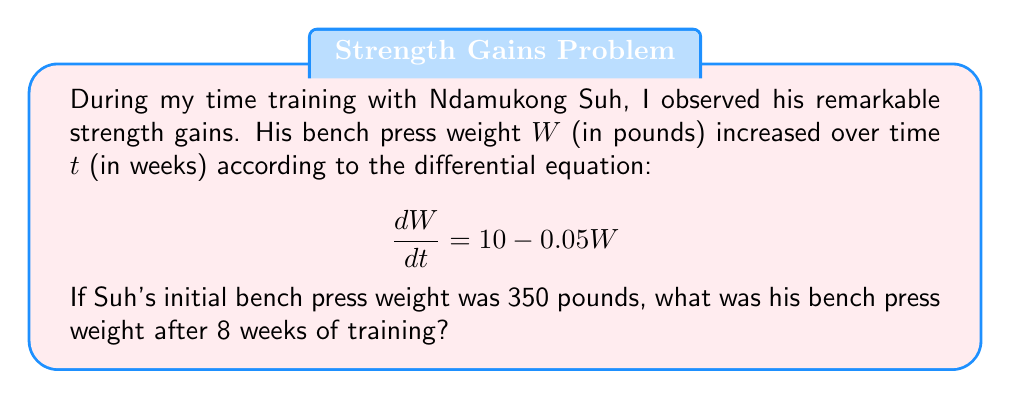Show me your answer to this math problem. Let's solve this step-by-step:

1) We have a first-order linear differential equation:
   $$\frac{dW}{dt} = 10 - 0.05W$$

2) This is in the form $\frac{dW}{dt} + PW = Q$, where $P = 0.05$ and $Q = 10$.

3) The general solution for this type of equation is:
   $$W = e^{-\int P dt}(\int Qe^{\int P dt}dt + C)$$

4) Solving the integrals:
   $\int P dt = 0.05t$
   $e^{\int P dt} = e^{0.05t}$

5) Substituting into the general solution:
   $$W = e^{-0.05t}(\int 10e^{0.05t}dt + C)$$

6) Solving the remaining integral:
   $$W = e^{-0.05t}(\frac{10}{0.05}e^{0.05t} + C) = 200 + Ce^{-0.05t}$$

7) Using the initial condition $W(0) = 350$:
   $350 = 200 + C$
   $C = 150$

8) So the particular solution is:
   $$W = 200 + 150e^{-0.05t}$$

9) To find W after 8 weeks, we substitute $t = 8$:
   $$W(8) = 200 + 150e^{-0.05(8)} \approx 395.96$$
Answer: $395.96$ pounds 